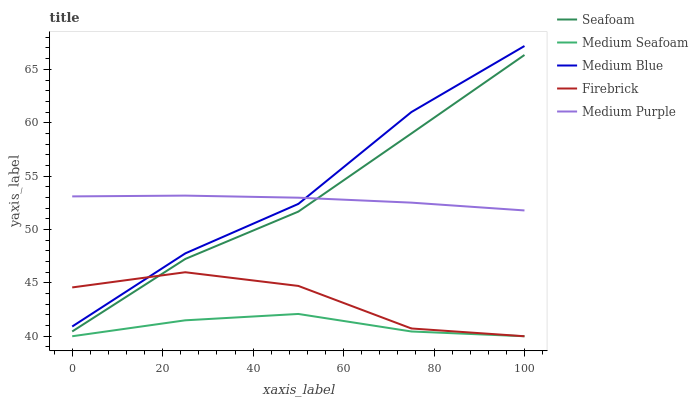Does Medium Seafoam have the minimum area under the curve?
Answer yes or no. Yes. Does Medium Blue have the maximum area under the curve?
Answer yes or no. Yes. Does Firebrick have the minimum area under the curve?
Answer yes or no. No. Does Firebrick have the maximum area under the curve?
Answer yes or no. No. Is Medium Purple the smoothest?
Answer yes or no. Yes. Is Firebrick the roughest?
Answer yes or no. Yes. Is Medium Blue the smoothest?
Answer yes or no. No. Is Medium Blue the roughest?
Answer yes or no. No. Does Firebrick have the lowest value?
Answer yes or no. Yes. Does Medium Blue have the lowest value?
Answer yes or no. No. Does Medium Blue have the highest value?
Answer yes or no. Yes. Does Firebrick have the highest value?
Answer yes or no. No. Is Medium Seafoam less than Seafoam?
Answer yes or no. Yes. Is Medium Purple greater than Firebrick?
Answer yes or no. Yes. Does Medium Purple intersect Medium Blue?
Answer yes or no. Yes. Is Medium Purple less than Medium Blue?
Answer yes or no. No. Is Medium Purple greater than Medium Blue?
Answer yes or no. No. Does Medium Seafoam intersect Seafoam?
Answer yes or no. No. 